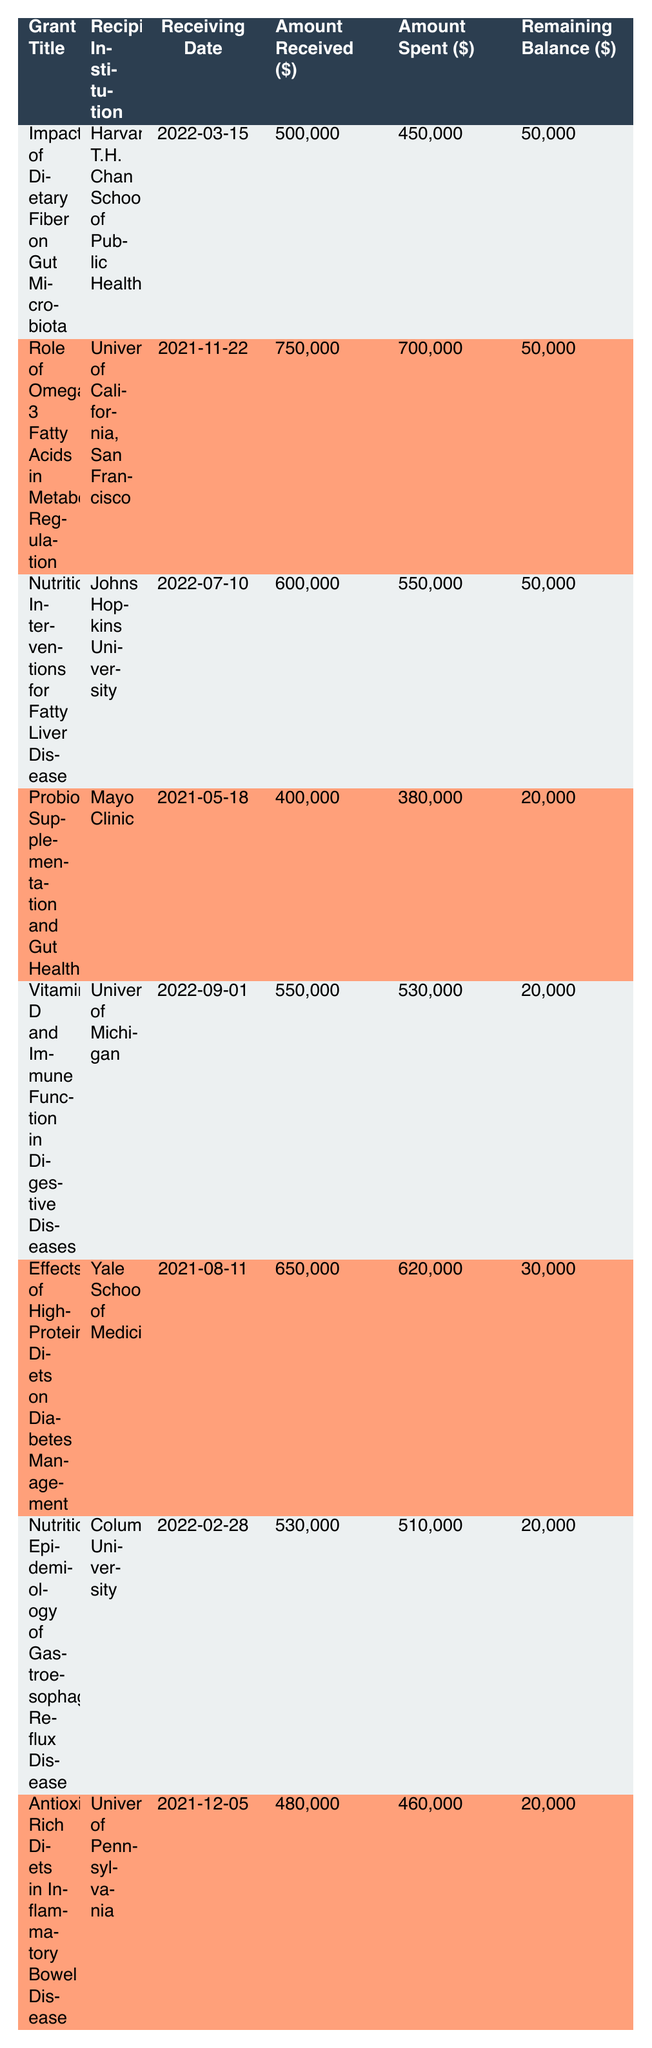What is the total amount received from all grants? To find the total amount received, sum the amounts received from each grant: 500000 + 750000 + 600000 + 400000 + 550000 + 650000 + 530000 + 480000 = 4060000.
Answer: 4060000 Which institution received the highest amount in funding? The institution that received the highest amount is the University of California, San Francisco, with an amount received of 750000.
Answer: University of California, San Francisco Is the remaining balance for the grant titled "Antioxidant-Rich Diets in Inflammatory Bowel Disease" more than 10000? The remaining balance for this grant is 20000, which is more than 10000.
Answer: Yes What is the average amount spent across all grants? To calculate the average amount spent, sum the amounts spent: 450000 + 700000 + 550000 + 380000 + 530000 + 620000 + 510000 + 460000 = 3800000. Then divide by the number of grants (8): 3800000 / 8 = 475000.
Answer: 475000 Which grant has the earliest receiving date? The grant with the earliest receiving date is "Probiotic Supplementation and Gut Health," received on 2021-05-18.
Answer: Probiotic Supplementation and Gut Health Did any of the grants have a remaining balance of 30000? Yes, the grant titled "Effects of High-Protein Diets on Diabetes Management" has a remaining balance of 30000.
Answer: Yes What is the total remaining balance across all grants? To find the total remaining balance, sum the remaining balances: 50000 + 50000 + 50000 + 20000 + 20000 + 30000 + 20000 + 20000 = 250000.
Answer: 250000 Which two grants have the same remaining balance of 20000? The two grants with a remaining balance of 20000 are "Probiotic Supplementation and Gut Health" and "Vitamin D and Immune Function in Digestive Diseases."
Answer: Probiotic Supplementation and Gut Health; Vitamin D and Immune Function in Digestive Diseases What is the difference between the highest and lowest amount spent? The highest amount spent is 700000, and the lowest is 380000. The difference is 700000 - 380000 = 320000.
Answer: 320000 